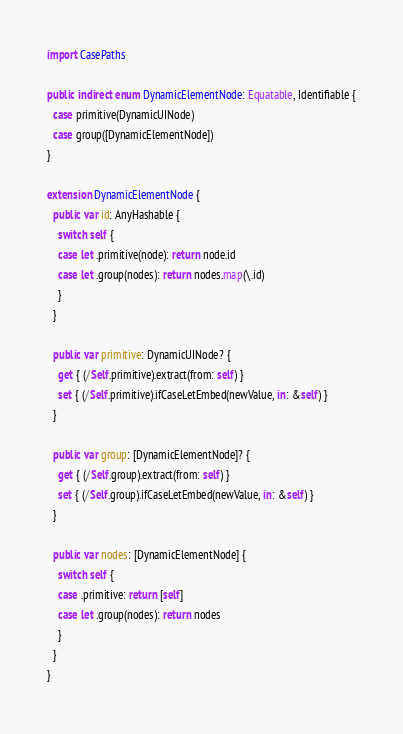<code> <loc_0><loc_0><loc_500><loc_500><_Swift_>import CasePaths

public indirect enum DynamicElementNode: Equatable, Identifiable {
  case primitive(DynamicUINode)
  case group([DynamicElementNode])
}

extension DynamicElementNode {
  public var id: AnyHashable {
    switch self {
    case let .primitive(node): return node.id
    case let .group(nodes): return nodes.map(\.id)
    }
  }
  
  public var primitive: DynamicUINode? {
    get { (/Self.primitive).extract(from: self) }
    set { (/Self.primitive).ifCaseLetEmbed(newValue, in: &self) }
  }
  
  public var group: [DynamicElementNode]? {
    get { (/Self.group).extract(from: self) }
    set { (/Self.group).ifCaseLetEmbed(newValue, in: &self) }
  }
  
  public var nodes: [DynamicElementNode] {
    switch self {
    case .primitive: return [self]
    case let .group(nodes): return nodes
    }
  }
}
</code> 